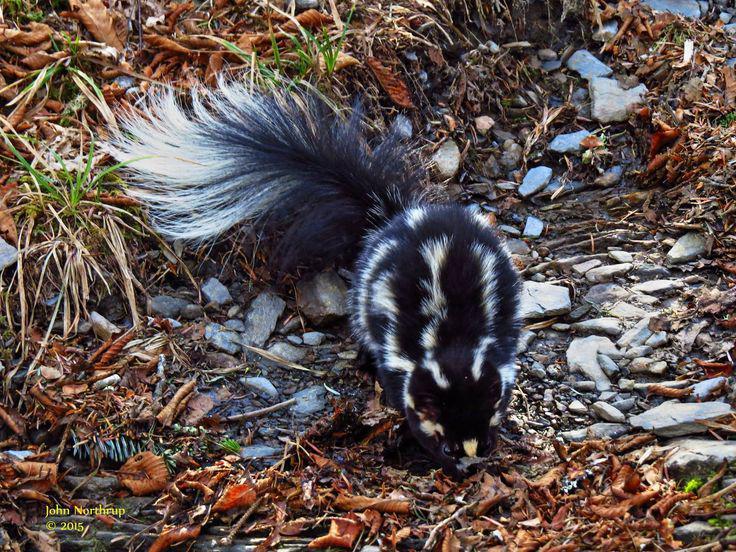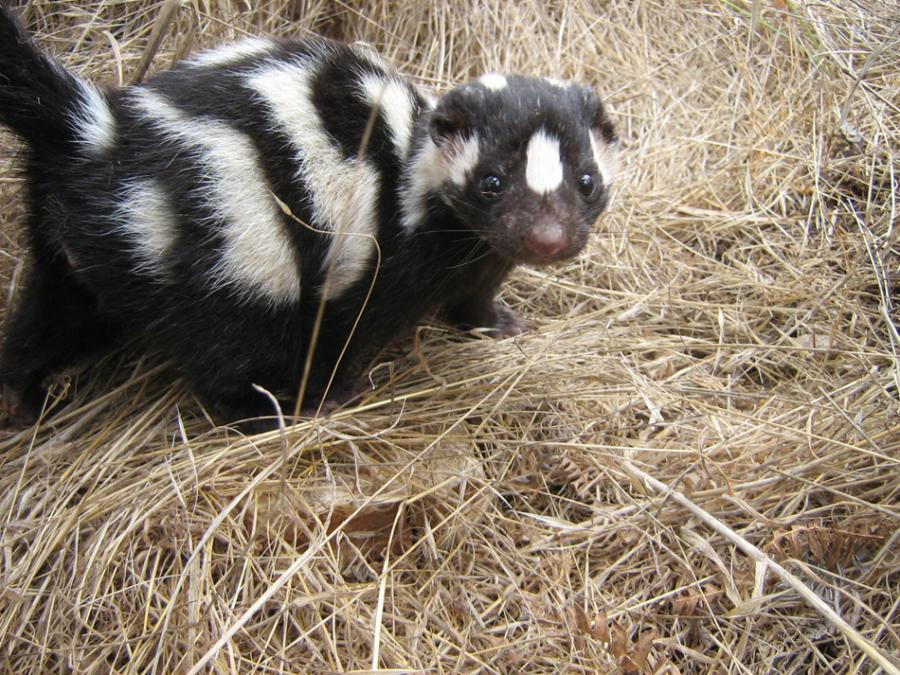The first image is the image on the left, the second image is the image on the right. Given the left and right images, does the statement "The left image features at least one skunk with a bold white stripe that starts at its head, and the right image features a skunk with more random and numerous stripes." hold true? Answer yes or no. No. 